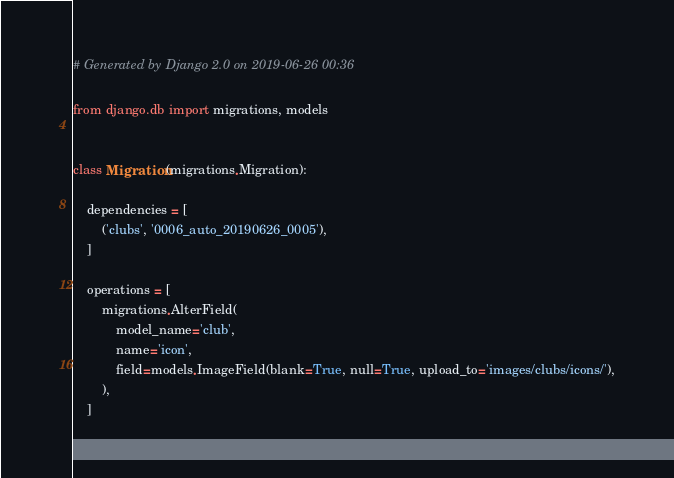Convert code to text. <code><loc_0><loc_0><loc_500><loc_500><_Python_># Generated by Django 2.0 on 2019-06-26 00:36

from django.db import migrations, models


class Migration(migrations.Migration):

    dependencies = [
        ('clubs', '0006_auto_20190626_0005'),
    ]

    operations = [
        migrations.AlterField(
            model_name='club',
            name='icon',
            field=models.ImageField(blank=True, null=True, upload_to='images/clubs/icons/'),
        ),
    ]
</code> 